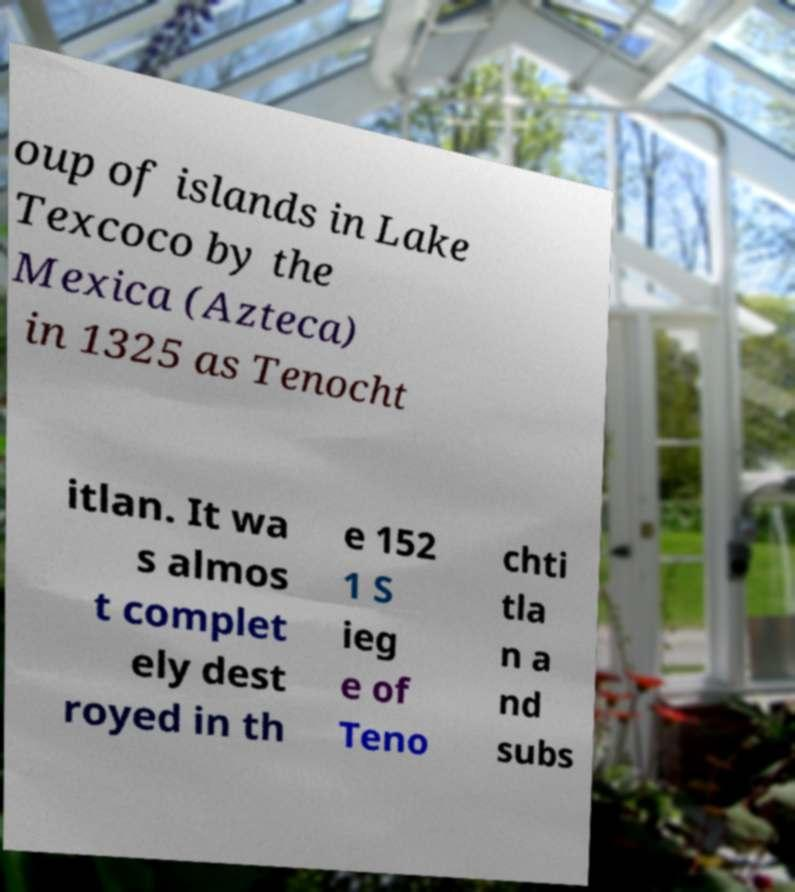Can you read and provide the text displayed in the image?This photo seems to have some interesting text. Can you extract and type it out for me? oup of islands in Lake Texcoco by the Mexica (Azteca) in 1325 as Tenocht itlan. It wa s almos t complet ely dest royed in th e 152 1 S ieg e of Teno chti tla n a nd subs 